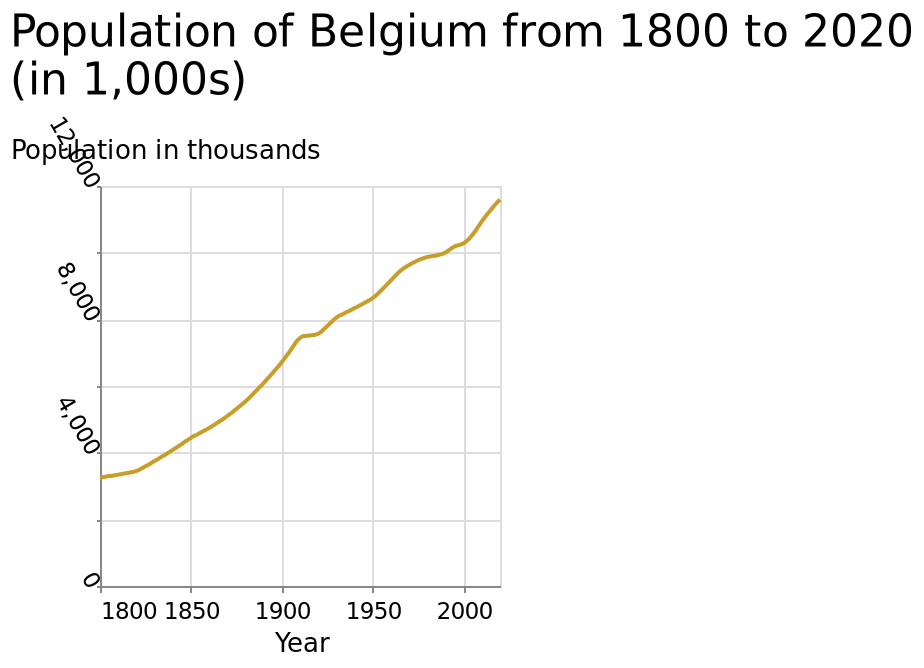<image>
please enumerates aspects of the construction of the chart This line plot is called Population of Belgium from 1800 to 2020 (in 1,000s). The y-axis shows Population in thousands with linear scale with a minimum of 0 and a maximum of 12,000 while the x-axis plots Year using linear scale of range 1800 to 2000. Offer a thorough analysis of the image. The population of Belgium has been steadily increasing since the 1800s. The rate was exponential up to around 1910, where it plateau'd for a few years until resuming a steady incline from around 1930 to 2020. Until when has the population of Belgium been increasing? The population of Belgium has been increasing from 1930 to 2020. 